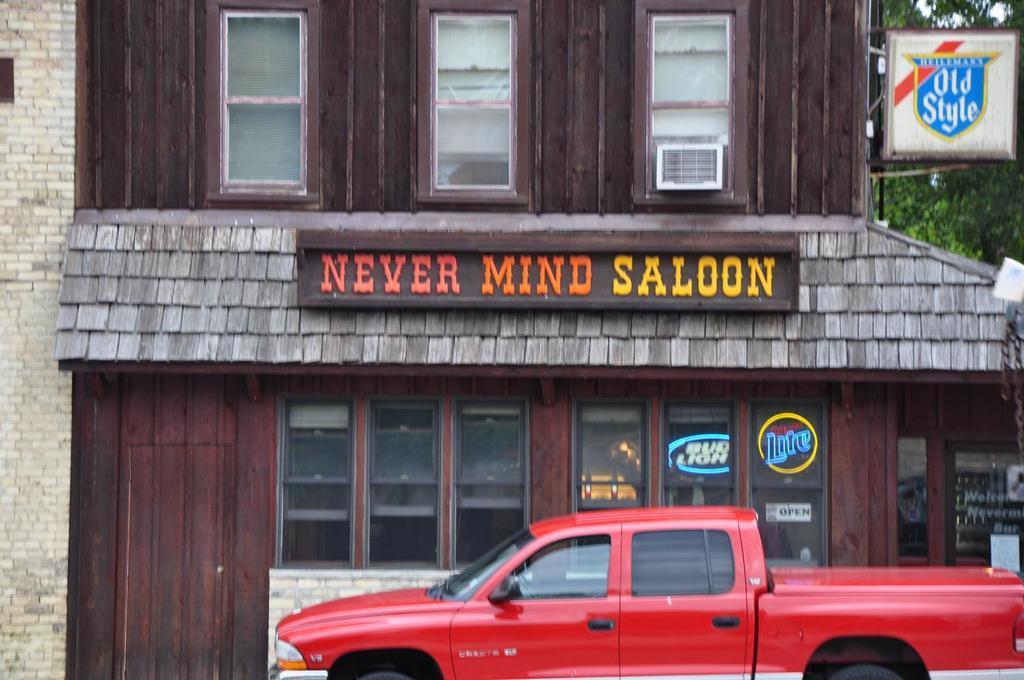How would you summarize this image in a sentence or two? In this picture we can see there is a red vehicle on the path and behind the vehicle there is a building with a name board and windows. On the right side of the building there is another board and trees. 